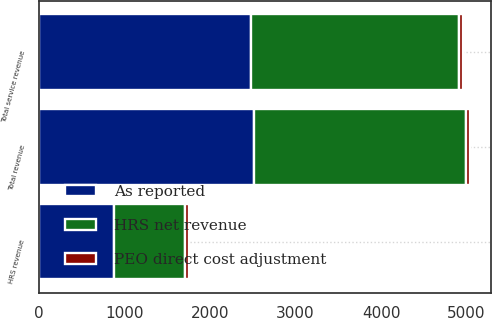<chart> <loc_0><loc_0><loc_500><loc_500><stacked_bar_chart><ecel><fcel>HRS revenue<fcel>Total service revenue<fcel>Total revenue<nl><fcel>As reported<fcel>878.9<fcel>2478.2<fcel>2518.9<nl><fcel>PEO direct cost adjustment<fcel>46.8<fcel>46.8<fcel>46.8<nl><fcel>HRS net revenue<fcel>832.1<fcel>2431.4<fcel>2472.1<nl></chart> 